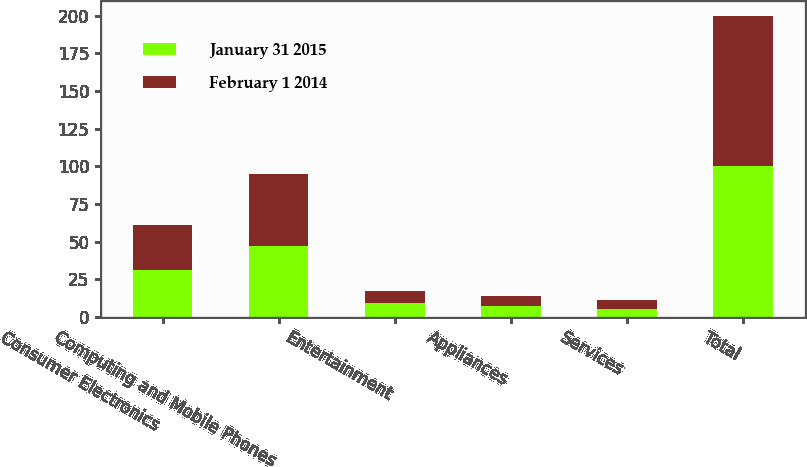Convert chart. <chart><loc_0><loc_0><loc_500><loc_500><stacked_bar_chart><ecel><fcel>Consumer Electronics<fcel>Computing and Mobile Phones<fcel>Entertainment<fcel>Appliances<fcel>Services<fcel>Total<nl><fcel>January 31 2015<fcel>31<fcel>47<fcel>9<fcel>7<fcel>5<fcel>100<nl><fcel>February 1 2014<fcel>30<fcel>48<fcel>8<fcel>7<fcel>6<fcel>100<nl></chart> 